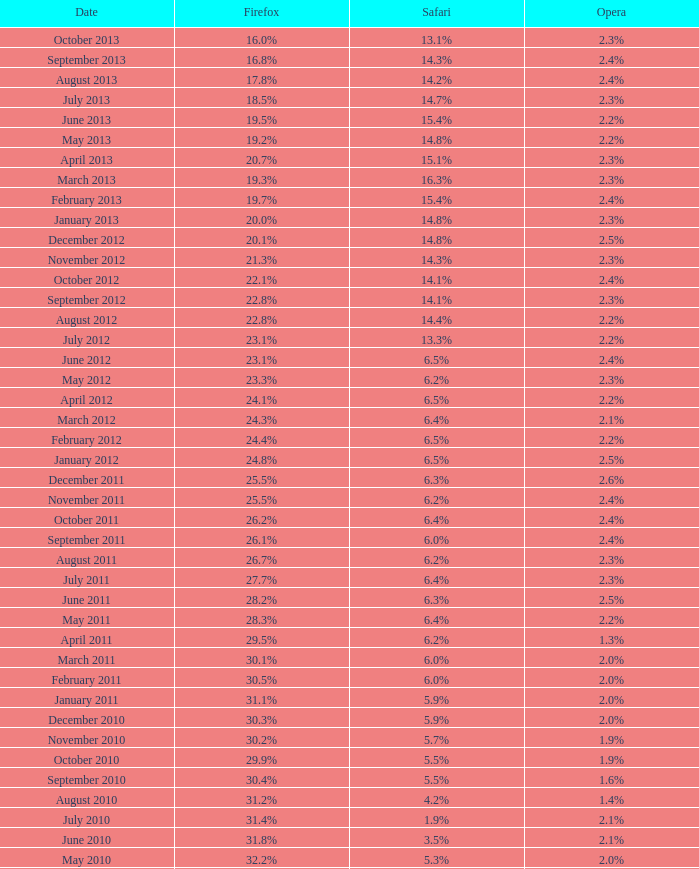What is the firefox value with a 1.9% safari? 31.4%. 